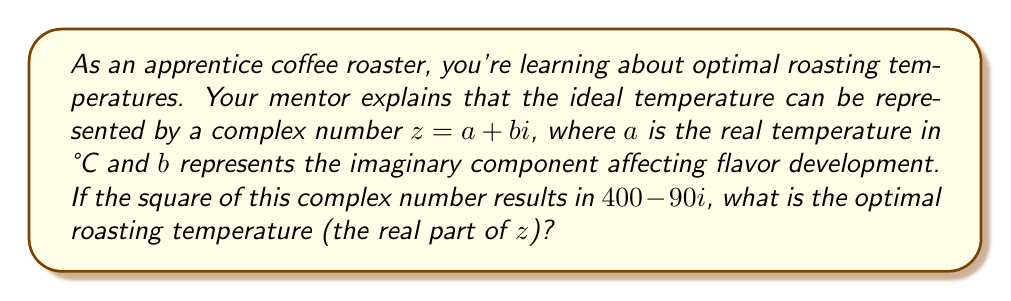Provide a solution to this math problem. Let's approach this step-by-step:

1) We're given that $z^2 = 400 - 90i$, where $z = a + bi$

2) Let's expand $(a + bi)^2$:
   $$(a + bi)^2 = a^2 - b^2 + 2abi$$

3) Equating the real and imaginary parts:
   $a^2 - b^2 = 400$ (real part)
   $2ab = -90$ (imaginary part)

4) From the imaginary part equation:
   $b = -\frac{45}{a}$

5) Substituting this into the real part equation:
   $$a^2 - (\frac{45}{a})^2 = 400$$

6) Multiply both sides by $a^2$:
   $$a^4 - 2025 = 400a^2$$

7) Rearrange:
   $$a^4 - 400a^2 - 2025 = 0$$

8) This is a quadratic equation in $a^2$. Let $y = a^2$:
   $$y^2 - 400y - 2025 = 0$$

9) Use the quadratic formula: $y = \frac{-b \pm \sqrt{b^2 - 4ac}}{2a}$
   $$y = \frac{400 \pm \sqrt{400^2 + 4(2025)}}{2} = \frac{400 \pm \sqrt{160000 + 8100}}{2} = \frac{400 \pm \sqrt{168100}}{2}$$

10) Simplify:
    $$y = \frac{400 \pm 410}{2}$$

11) We need the positive solution:
    $$y = \frac{400 + 410}{2} = 405$$

12) Remember, $y = a^2$, so:
    $$a = \sqrt{405} = 20.12$$

Therefore, the optimal roasting temperature (the real part of $z$) is approximately 20.12°C.
Answer: $20.12\text{°C}$ 